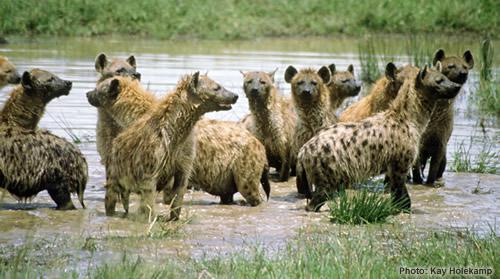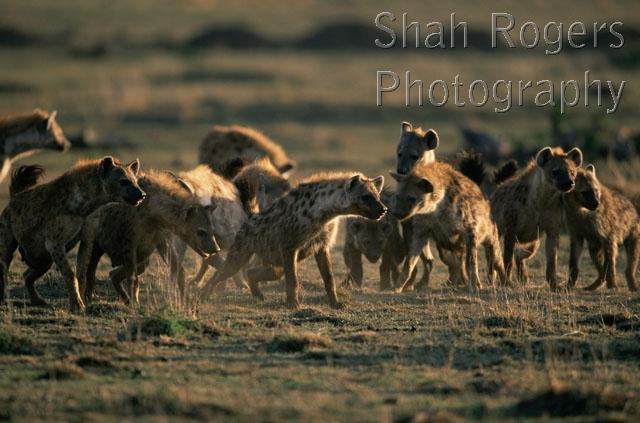The first image is the image on the left, the second image is the image on the right. Assess this claim about the two images: "Right image shows a close grouping of no more than five hyenas.". Correct or not? Answer yes or no. No. 